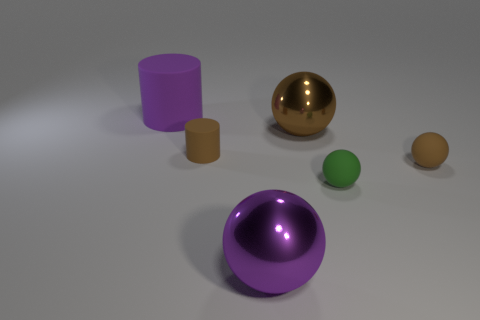Are there any other things that are the same color as the small rubber cylinder?
Your answer should be very brief. Yes. Does the tiny rubber cylinder have the same color as the large shiny object that is behind the green matte object?
Your answer should be compact. Yes. Is the color of the big shiny ball in front of the tiny brown sphere the same as the big matte cylinder?
Give a very brief answer. Yes. There is a small sphere that is made of the same material as the green object; what is its color?
Keep it short and to the point. Brown. There is a big rubber object; does it have the same shape as the tiny brown rubber object that is on the left side of the big purple ball?
Ensure brevity in your answer.  Yes. There is a large cylinder; are there any brown metal balls in front of it?
Provide a short and direct response. Yes. There is a small object that is the same color as the tiny matte cylinder; what is its material?
Your answer should be very brief. Rubber. Is the size of the brown shiny sphere the same as the purple matte cylinder that is behind the purple metallic object?
Provide a short and direct response. Yes. Are there any big things that have the same color as the large matte cylinder?
Provide a short and direct response. Yes. Is there a green rubber thing that has the same shape as the purple shiny thing?
Make the answer very short. Yes. 